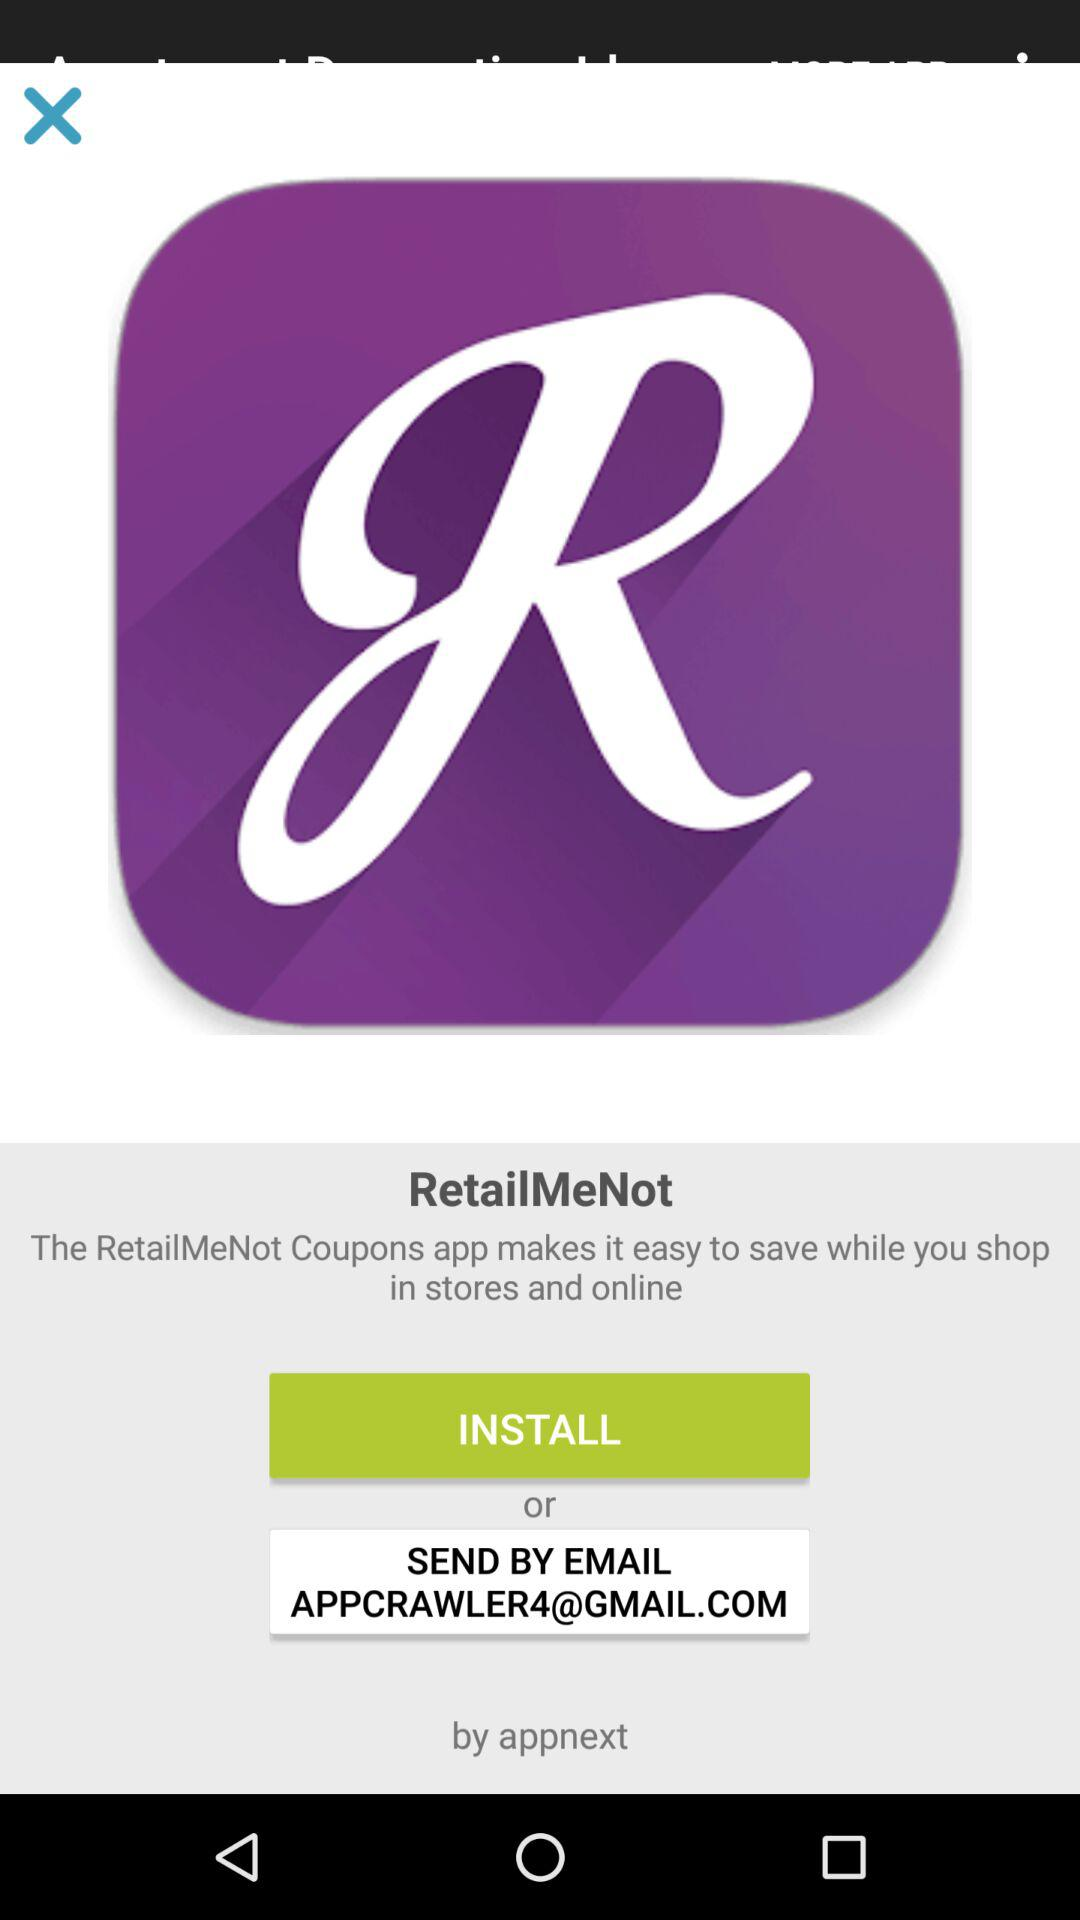By whom is the "RetailMeNot" app powered? The "RetailMeNot" app is powered by "Appnext". 